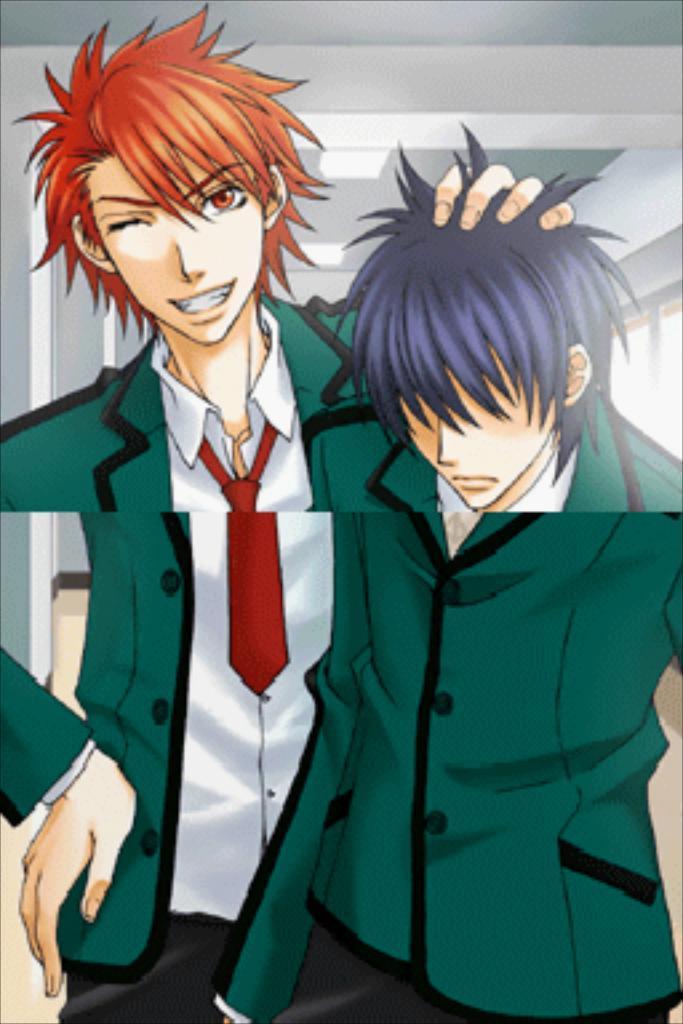In one or two sentences, can you explain what this image depicts? In this image there are cartoons of people. On the right side of the image there is a glass window. On top of the image there are lights. 